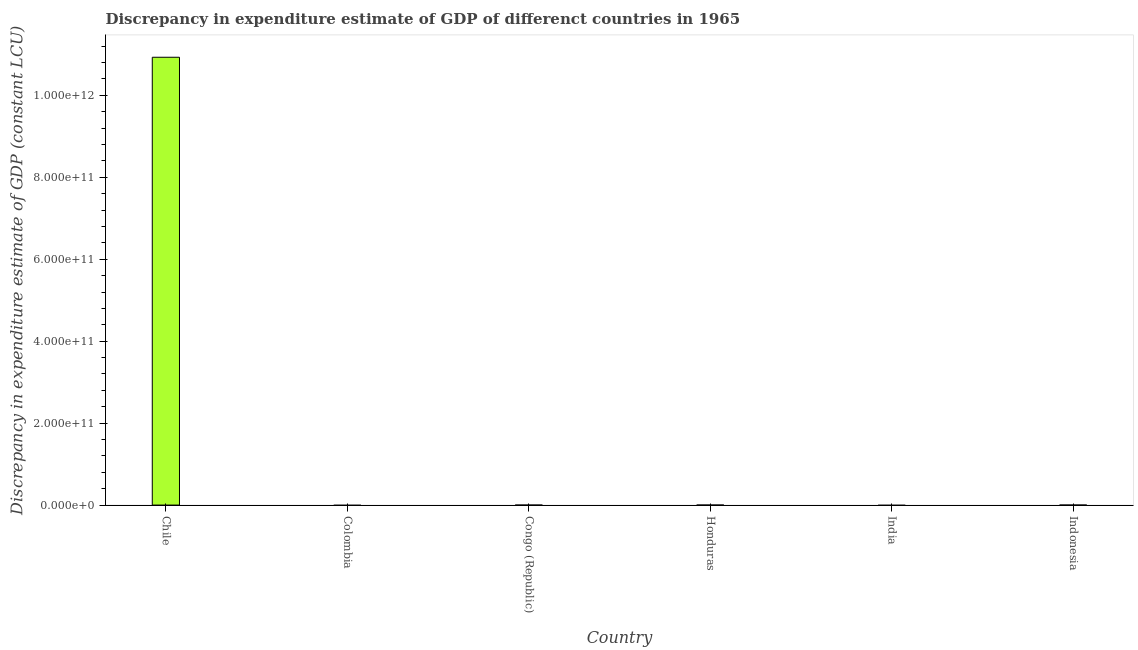What is the title of the graph?
Your response must be concise. Discrepancy in expenditure estimate of GDP of differenct countries in 1965. What is the label or title of the Y-axis?
Give a very brief answer. Discrepancy in expenditure estimate of GDP (constant LCU). Across all countries, what is the maximum discrepancy in expenditure estimate of gdp?
Give a very brief answer. 1.09e+12. What is the sum of the discrepancy in expenditure estimate of gdp?
Provide a succinct answer. 1.09e+12. What is the difference between the discrepancy in expenditure estimate of gdp in Chile and Honduras?
Your answer should be very brief. 1.09e+12. What is the average discrepancy in expenditure estimate of gdp per country?
Provide a succinct answer. 1.82e+11. In how many countries, is the discrepancy in expenditure estimate of gdp greater than 560000000000 LCU?
Your answer should be compact. 1. What is the difference between the highest and the lowest discrepancy in expenditure estimate of gdp?
Your response must be concise. 1.09e+12. In how many countries, is the discrepancy in expenditure estimate of gdp greater than the average discrepancy in expenditure estimate of gdp taken over all countries?
Ensure brevity in your answer.  1. Are all the bars in the graph horizontal?
Your answer should be very brief. No. How many countries are there in the graph?
Your answer should be compact. 6. What is the difference between two consecutive major ticks on the Y-axis?
Give a very brief answer. 2.00e+11. What is the Discrepancy in expenditure estimate of GDP (constant LCU) of Chile?
Provide a short and direct response. 1.09e+12. What is the Discrepancy in expenditure estimate of GDP (constant LCU) in Colombia?
Provide a succinct answer. 0. What is the Discrepancy in expenditure estimate of GDP (constant LCU) of Congo (Republic)?
Your answer should be very brief. 0. What is the Discrepancy in expenditure estimate of GDP (constant LCU) of Honduras?
Your response must be concise. 2.85e+04. What is the Discrepancy in expenditure estimate of GDP (constant LCU) in India?
Offer a very short reply. 0. What is the difference between the Discrepancy in expenditure estimate of GDP (constant LCU) in Chile and Honduras?
Ensure brevity in your answer.  1.09e+12. What is the ratio of the Discrepancy in expenditure estimate of GDP (constant LCU) in Chile to that in Honduras?
Offer a very short reply. 3.83e+07. 